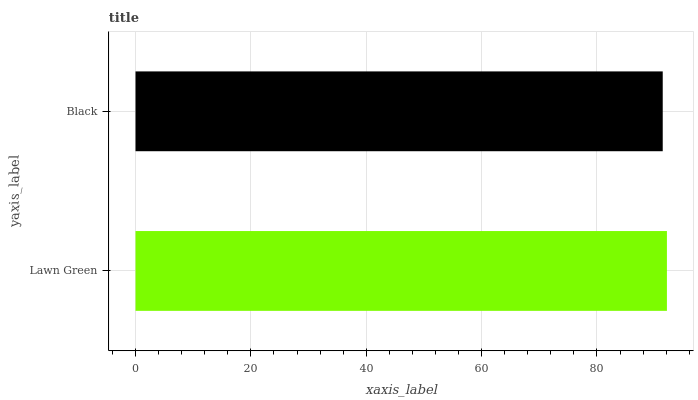Is Black the minimum?
Answer yes or no. Yes. Is Lawn Green the maximum?
Answer yes or no. Yes. Is Black the maximum?
Answer yes or no. No. Is Lawn Green greater than Black?
Answer yes or no. Yes. Is Black less than Lawn Green?
Answer yes or no. Yes. Is Black greater than Lawn Green?
Answer yes or no. No. Is Lawn Green less than Black?
Answer yes or no. No. Is Lawn Green the high median?
Answer yes or no. Yes. Is Black the low median?
Answer yes or no. Yes. Is Black the high median?
Answer yes or no. No. Is Lawn Green the low median?
Answer yes or no. No. 